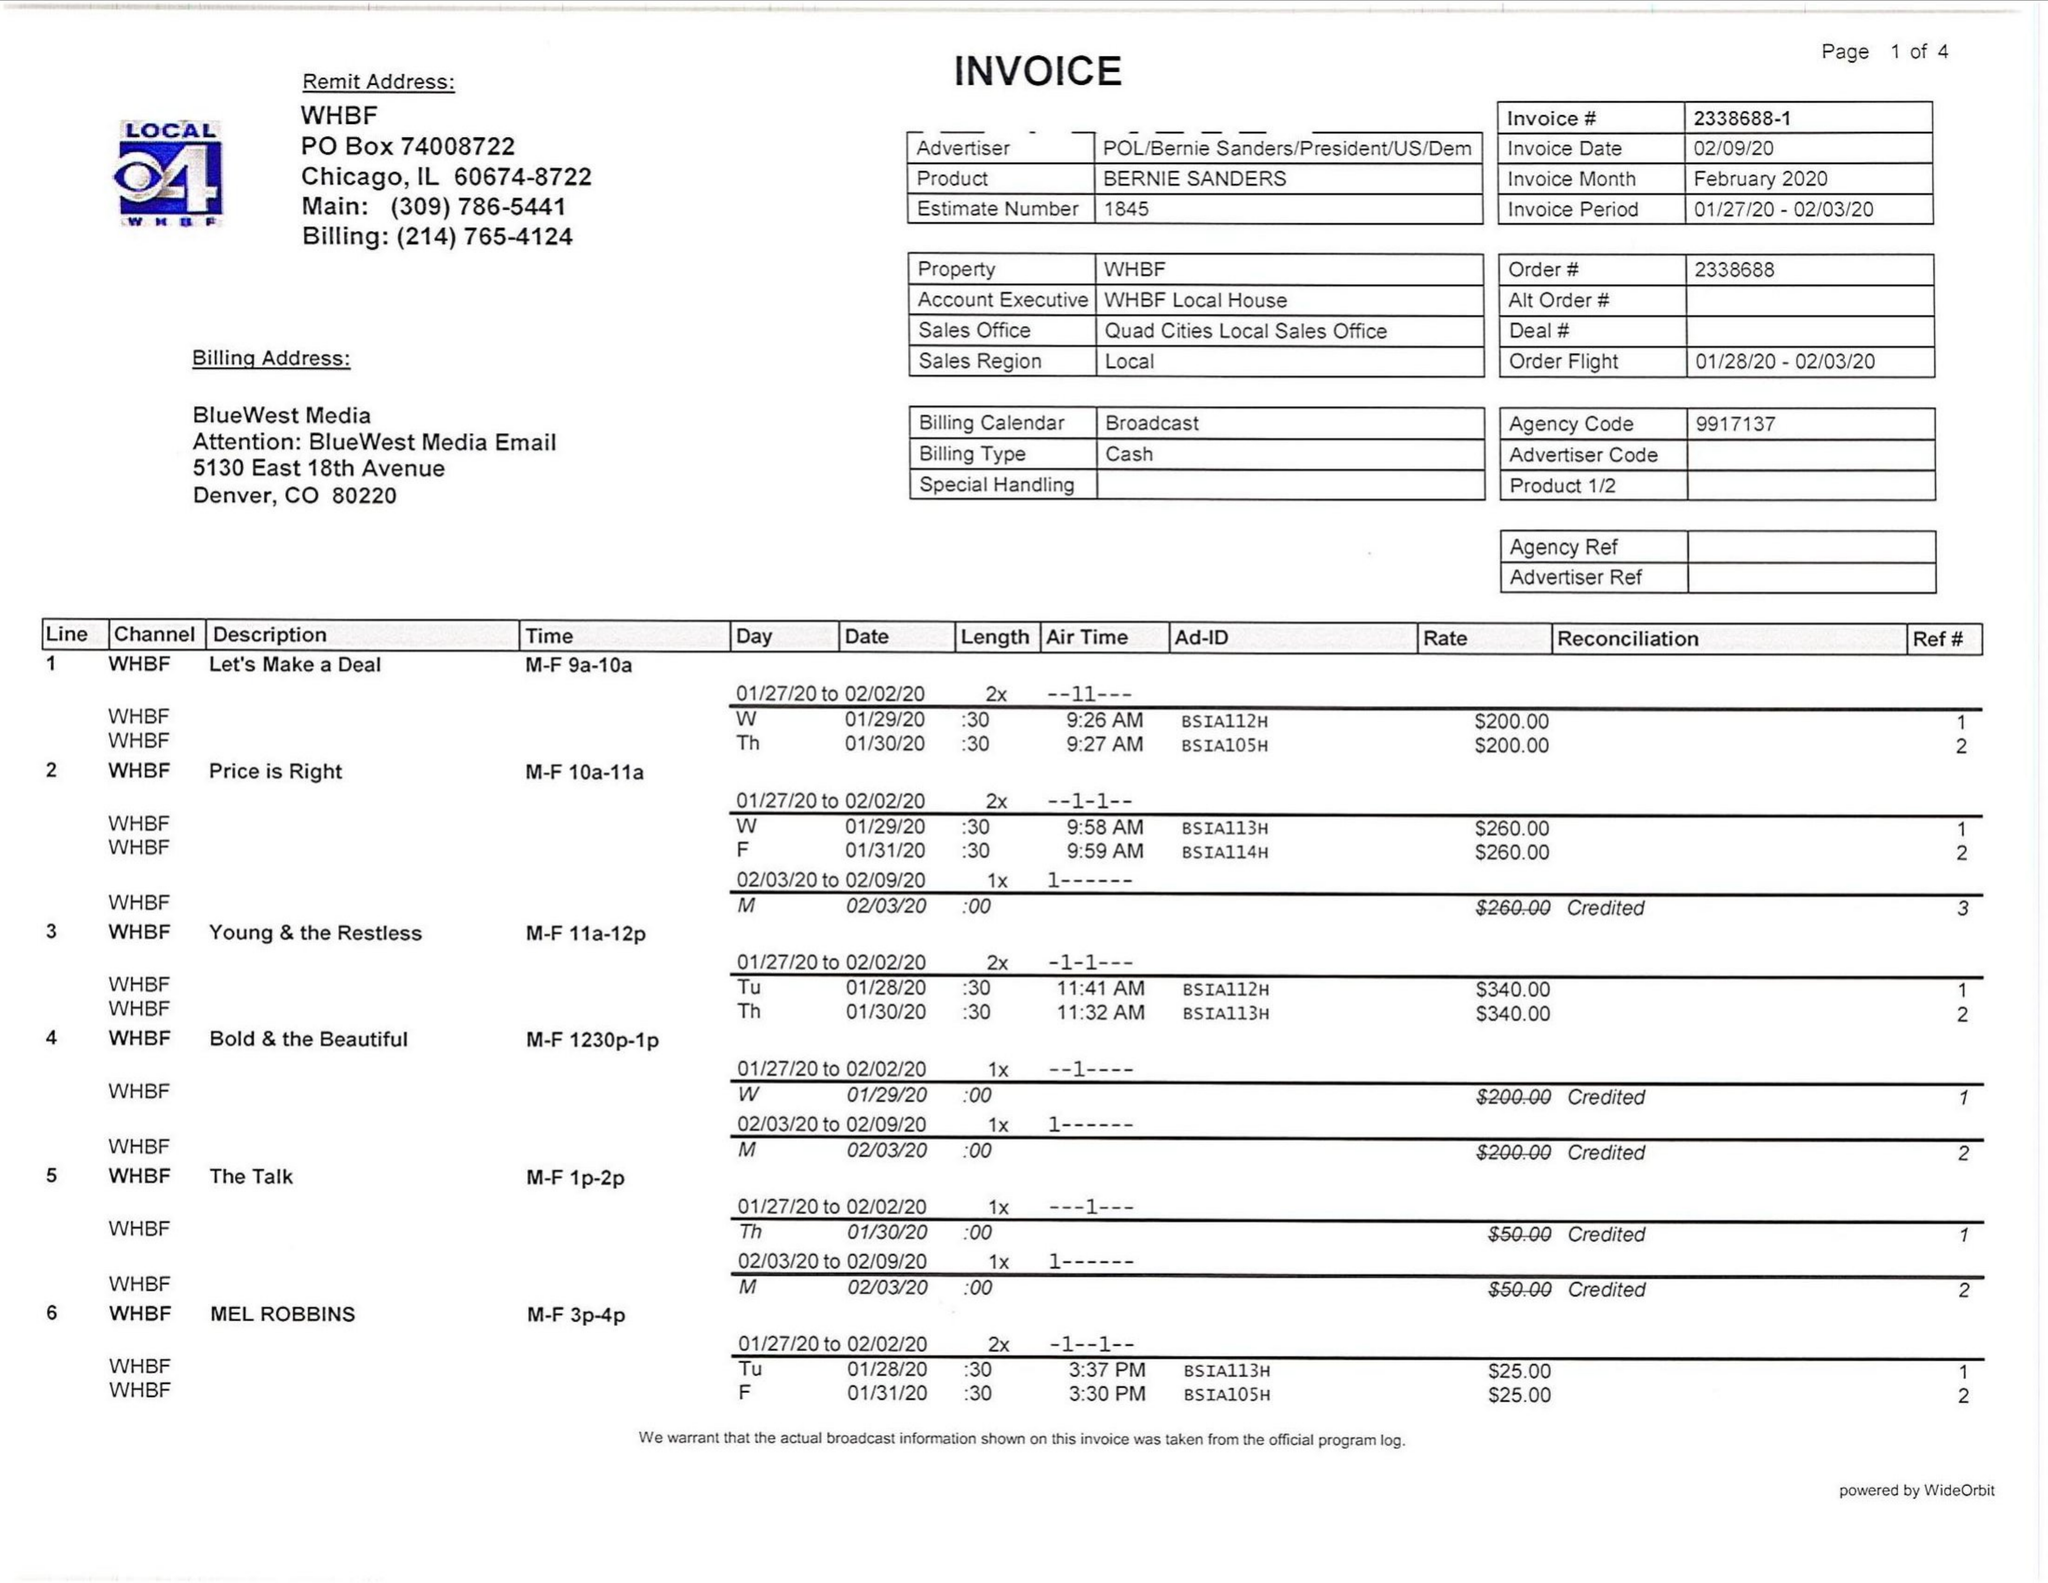What is the value for the flight_to?
Answer the question using a single word or phrase. 02/03/20 